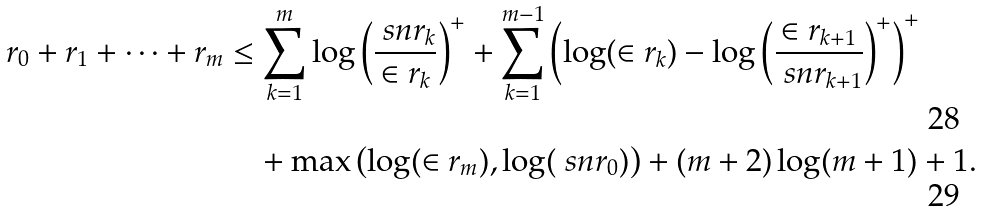<formula> <loc_0><loc_0><loc_500><loc_500>r _ { 0 } + r _ { 1 } + \dots + r _ { m } & \leq \sum _ { k = 1 } ^ { m } \log \left ( \frac { \ s n r _ { k } } { \in r _ { k } } \right ) ^ { + } + \sum _ { k = 1 } ^ { m - 1 } \left ( \log ( \in r _ { k } ) - \log \left ( \frac { \in r _ { k + 1 } } { \ s n r _ { k + 1 } } \right ) ^ { + } \right ) ^ { + } \\ & \quad + \max \left ( \log ( \in r _ { m } ) , \log ( \ s n r _ { 0 } ) \right ) + ( m + 2 ) \log ( m + 1 ) + 1 .</formula> 